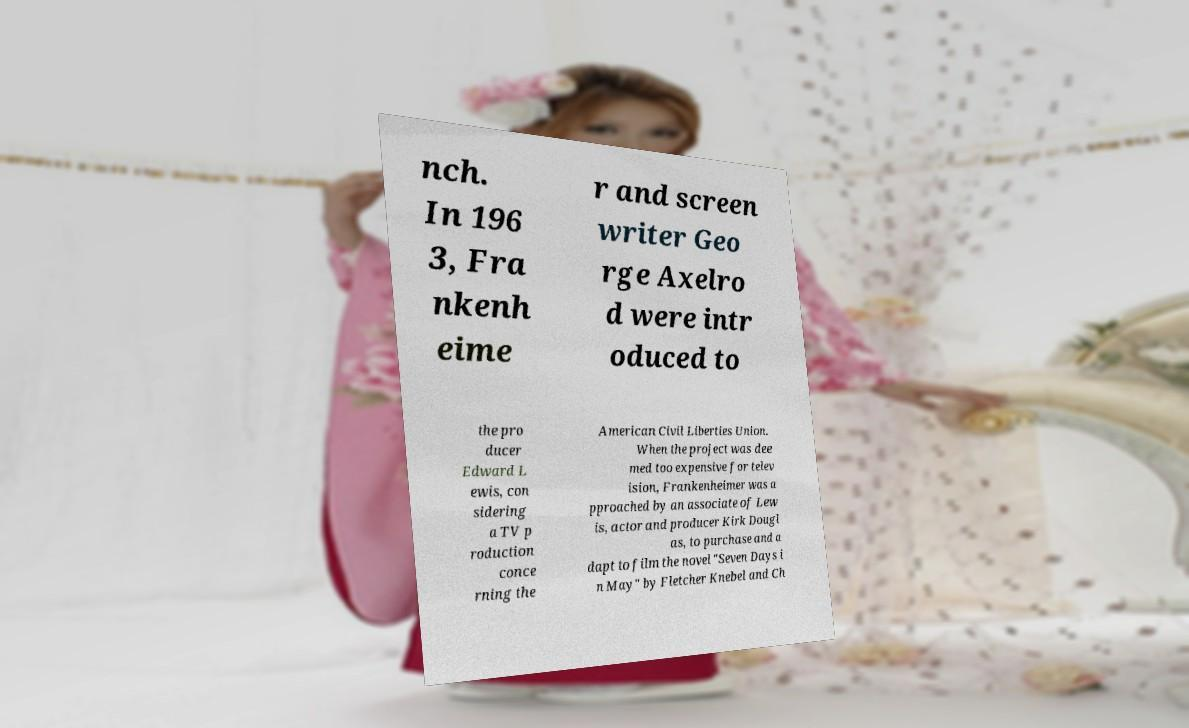For documentation purposes, I need the text within this image transcribed. Could you provide that? nch. In 196 3, Fra nkenh eime r and screen writer Geo rge Axelro d were intr oduced to the pro ducer Edward L ewis, con sidering a TV p roduction conce rning the American Civil Liberties Union. When the project was dee med too expensive for telev ision, Frankenheimer was a pproached by an associate of Lew is, actor and producer Kirk Dougl as, to purchase and a dapt to film the novel "Seven Days i n May" by Fletcher Knebel and Ch 